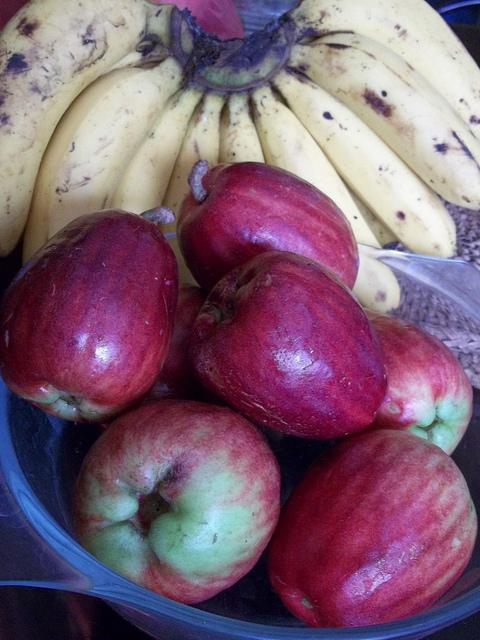Which country grows most bananas? Please explain your reasoning. india. Bananas are grown in india. 